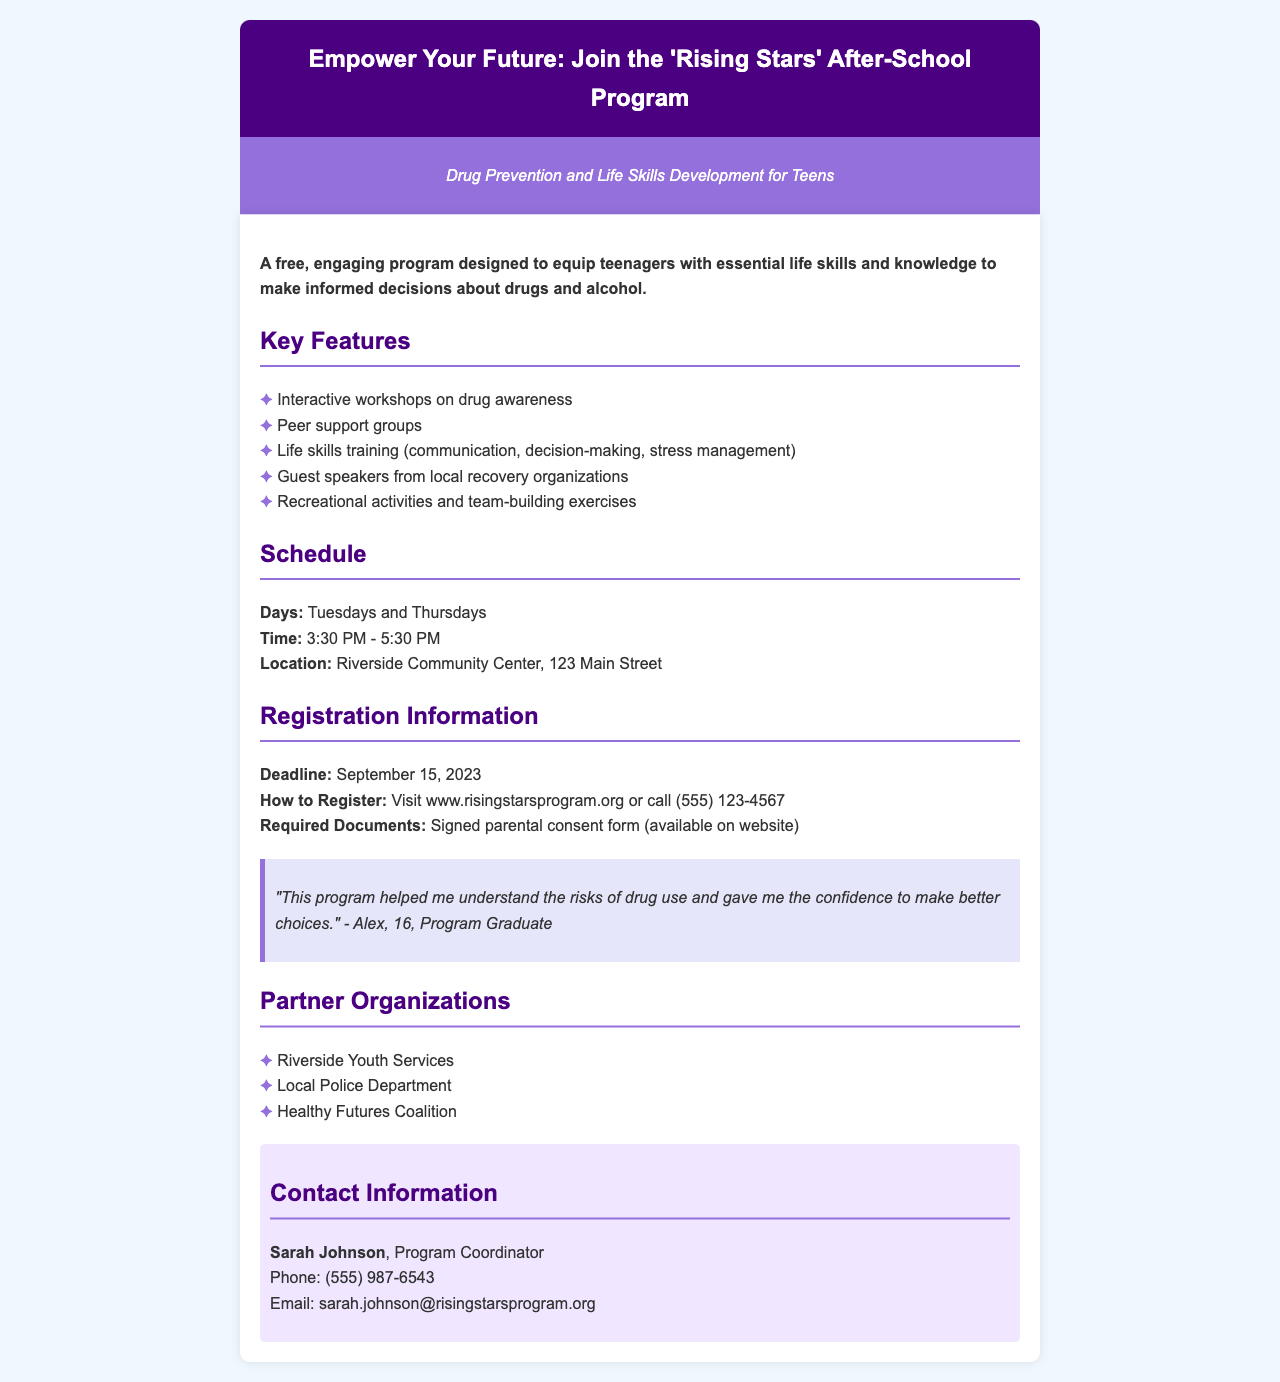What is the program's name? The name of the program, as stated in the document, is "Rising Stars After-School Program."
Answer: Rising Stars After-School Program What days does the program occur? The document specifies that the program takes place on Tuesdays and Thursdays.
Answer: Tuesdays and Thursdays What time does the program start? According to the document, the program starts at 3:30 PM.
Answer: 3:30 PM When is the registration deadline? The document mentions that the registration deadline is September 15, 2023.
Answer: September 15, 2023 Who is the program coordinator? The name of the program coordinator listed in the document is Sarah Johnson.
Answer: Sarah Johnson What types of activities are included in the program? The document lists activities such as workshops on drug awareness and life skills training.
Answer: Workshops on drug awareness; life skills training Why might a teenager want to join this program? Teens might join to gain essential life skills and knowledge for making informed decisions about drugs and alcohol.
Answer: To gain essential life skills and knowledge What is required to register for the program? The document states that a signed parental consent form is required for registration.
Answer: Signed parental consent form 